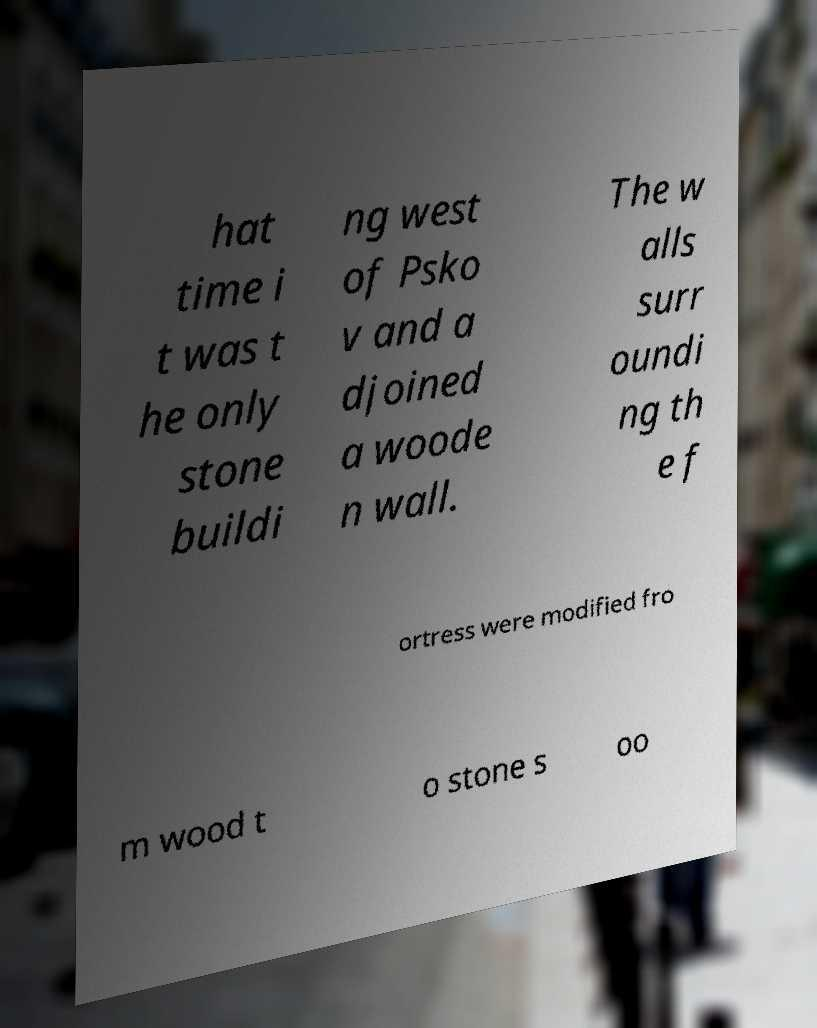Can you read and provide the text displayed in the image?This photo seems to have some interesting text. Can you extract and type it out for me? hat time i t was t he only stone buildi ng west of Psko v and a djoined a woode n wall. The w alls surr oundi ng th e f ortress were modified fro m wood t o stone s oo 